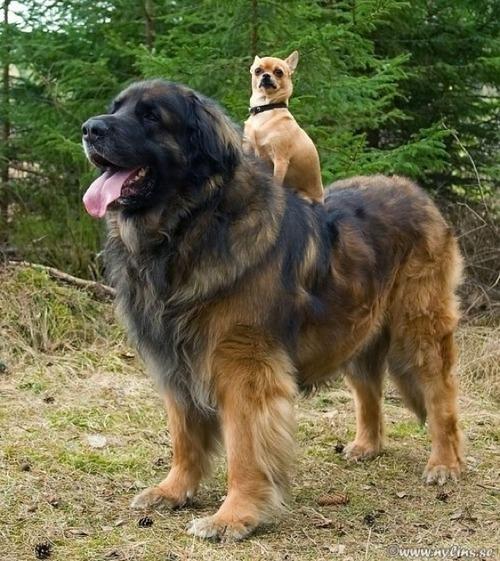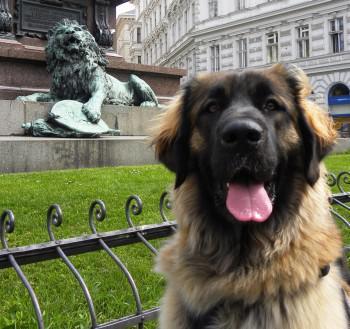The first image is the image on the left, the second image is the image on the right. Examine the images to the left and right. Is the description "There are two dogs in one of the images." accurate? Answer yes or no. Yes. 